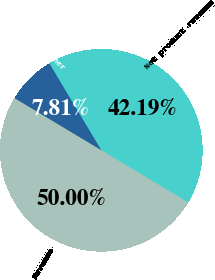Convert chart to OTSL. <chart><loc_0><loc_0><loc_500><loc_500><pie_chart><fcel>Net product revenue<fcel>Collaboration and other<fcel>Revenue<nl><fcel>42.19%<fcel>7.81%<fcel>50.0%<nl></chart> 